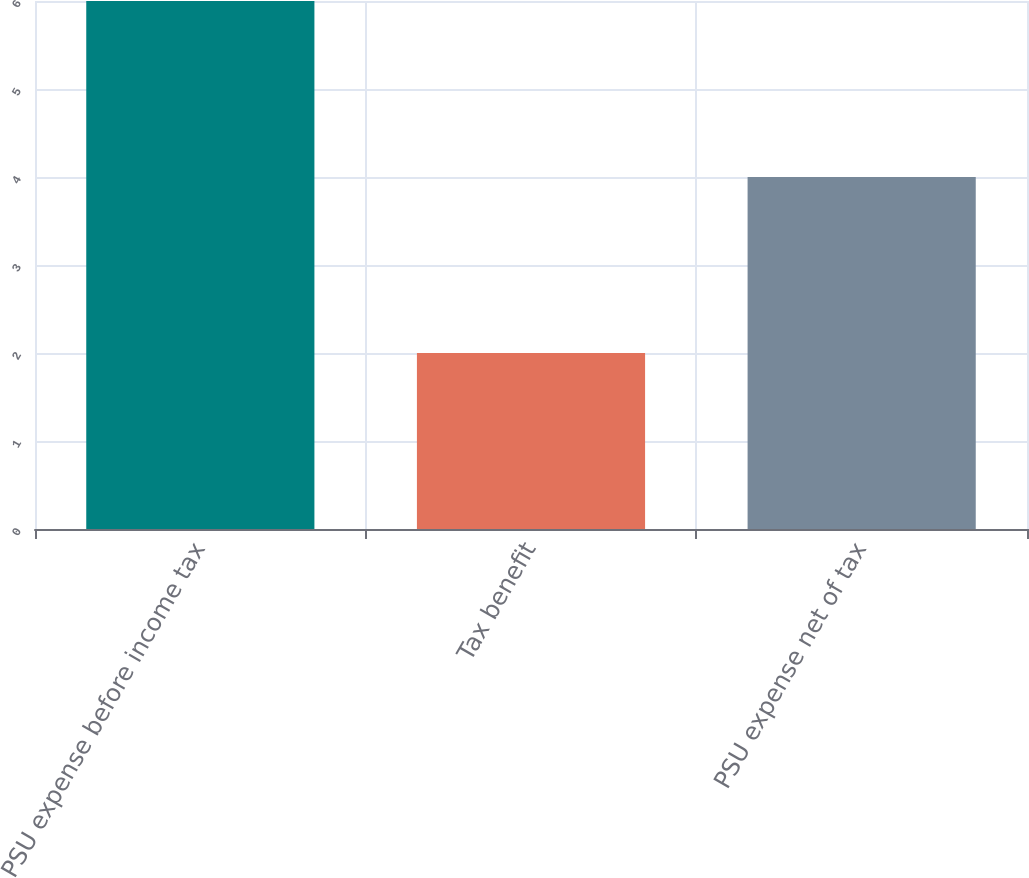<chart> <loc_0><loc_0><loc_500><loc_500><bar_chart><fcel>PSU expense before income tax<fcel>Tax benefit<fcel>PSU expense net of tax<nl><fcel>6<fcel>2<fcel>4<nl></chart> 